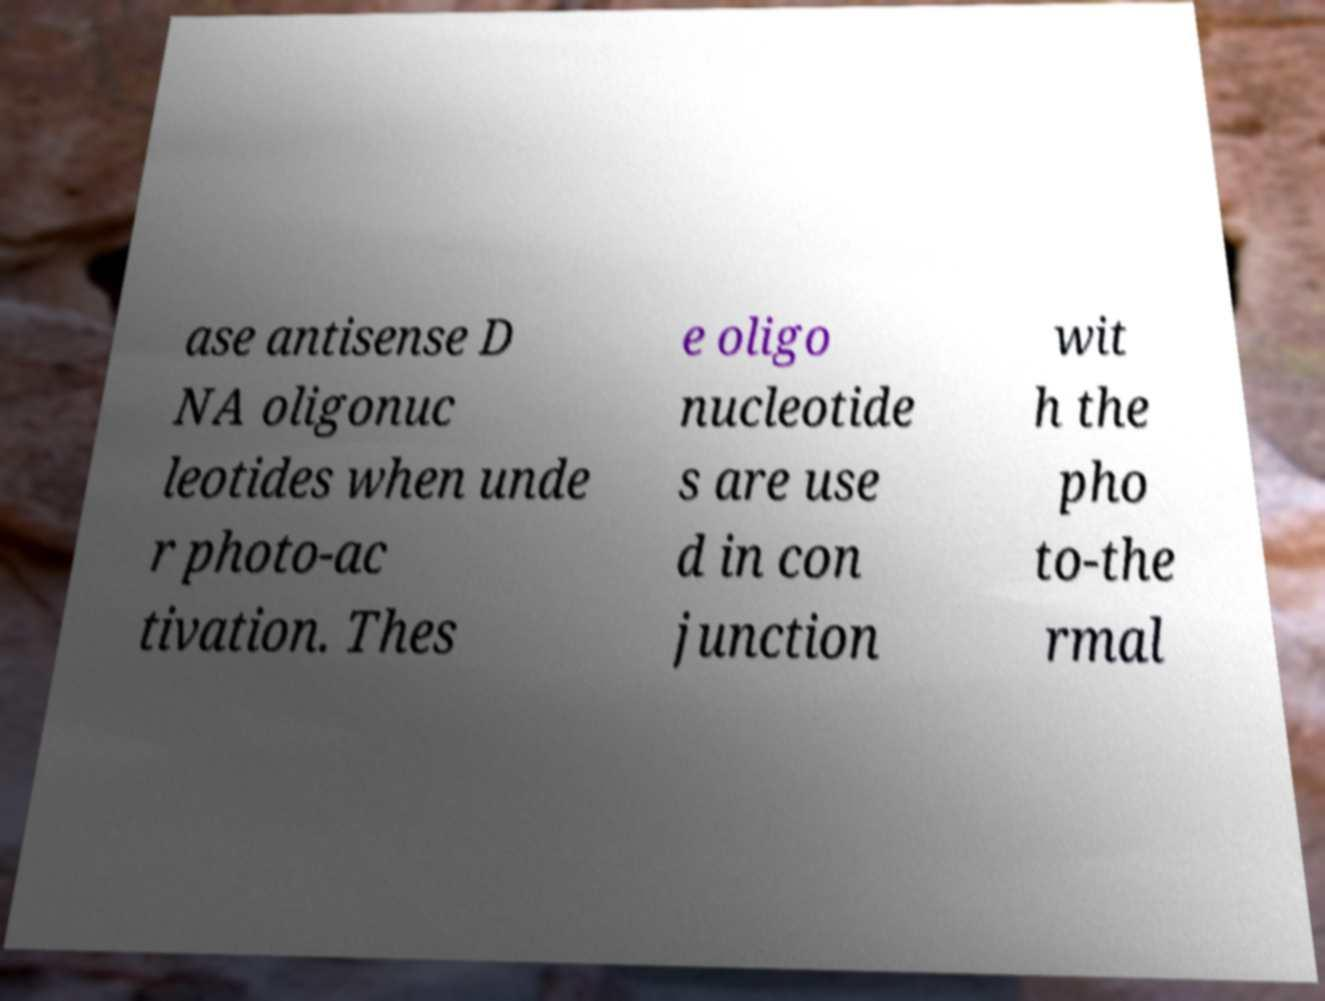For documentation purposes, I need the text within this image transcribed. Could you provide that? ase antisense D NA oligonuc leotides when unde r photo-ac tivation. Thes e oligo nucleotide s are use d in con junction wit h the pho to-the rmal 